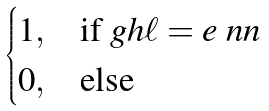Convert formula to latex. <formula><loc_0><loc_0><loc_500><loc_500>\begin{cases} 1 , & \text {if $gh\ell=e$} \ n n \\ 0 , & \text {else} \end{cases}</formula> 